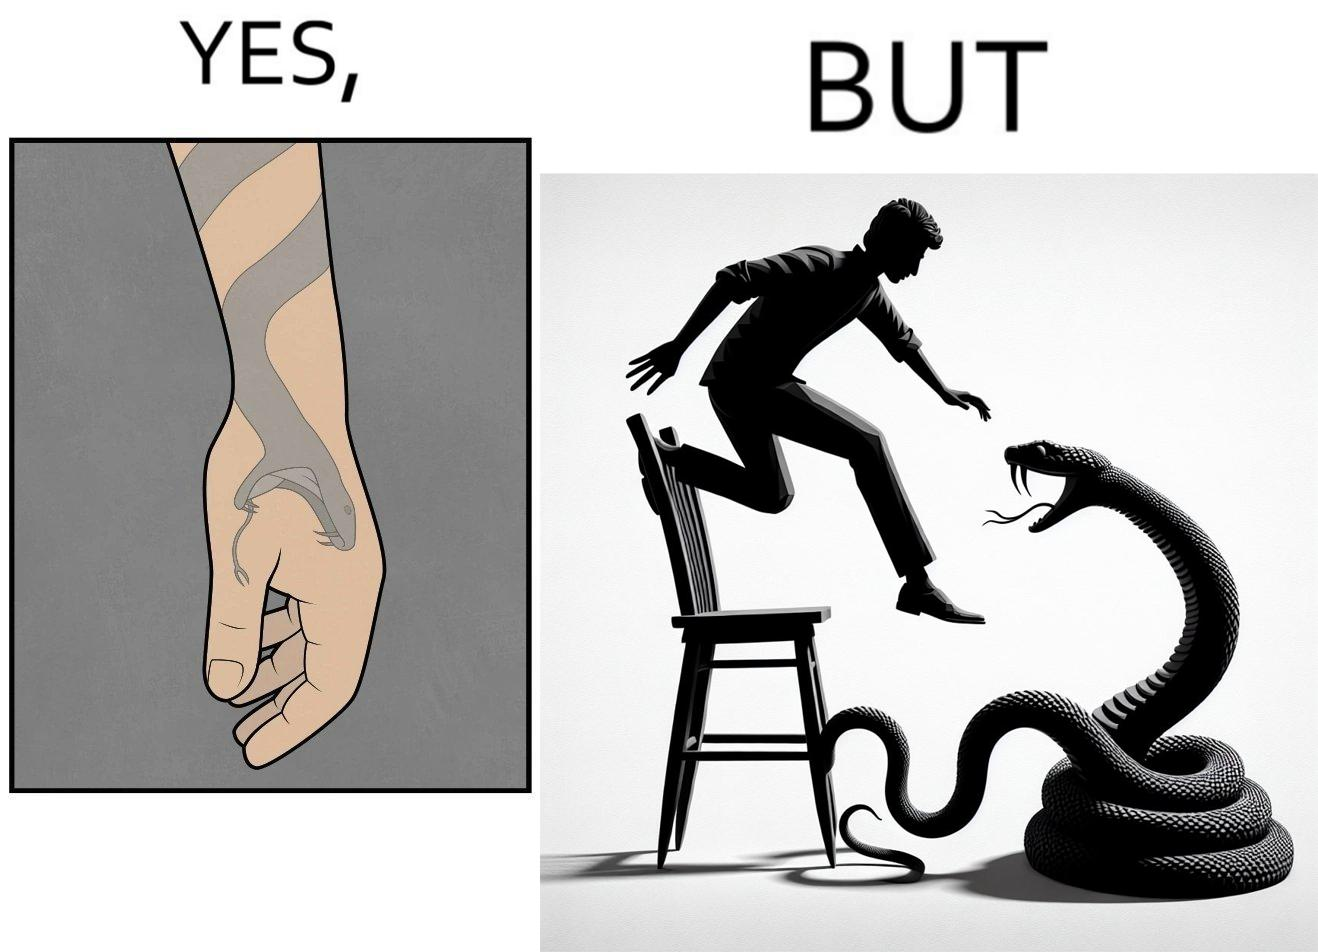Describe the satirical element in this image. The image is ironic, because in the first image the tattoo of a snake on someone's hand may give us a hint about how powerful or brave the person can be who is having this tattoo but in the second image the person with same tattoo is seen frightened due to a snake in his house 